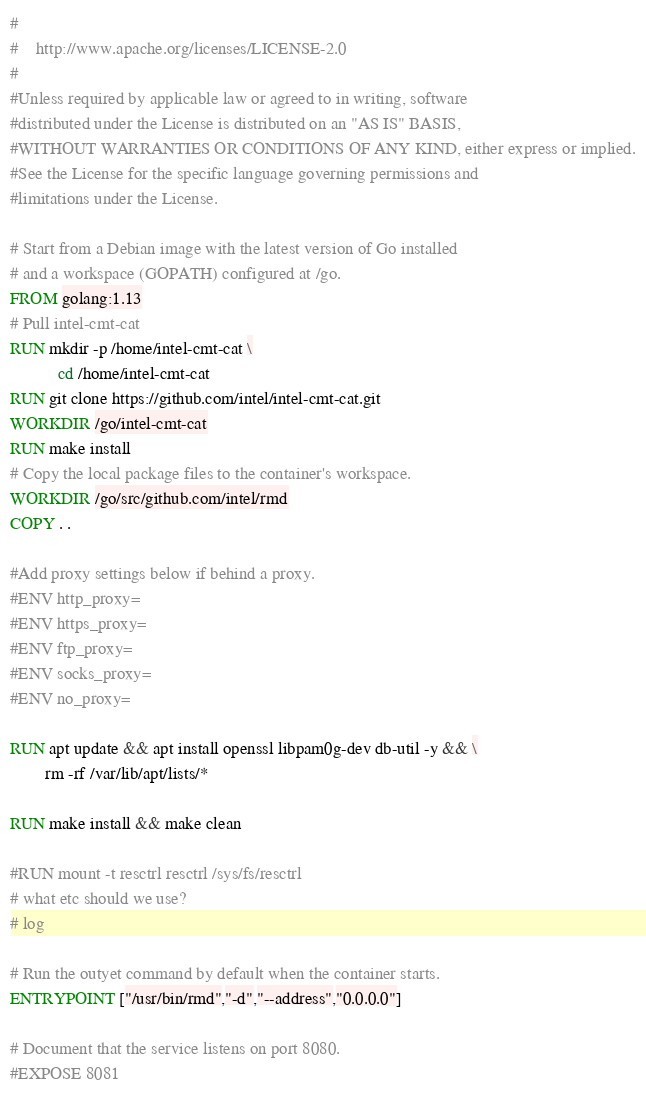<code> <loc_0><loc_0><loc_500><loc_500><_Dockerfile_>#
#    http://www.apache.org/licenses/LICENSE-2.0
#
#Unless required by applicable law or agreed to in writing, software
#distributed under the License is distributed on an "AS IS" BASIS,
#WITHOUT WARRANTIES OR CONDITIONS OF ANY KIND, either express or implied.
#See the License for the specific language governing permissions and
#limitations under the License.

# Start from a Debian image with the latest version of Go installed
# and a workspace (GOPATH) configured at /go.
FROM golang:1.13  
# Pull intel-cmt-cat
RUN mkdir -p /home/intel-cmt-cat \
           cd /home/intel-cmt-cat
RUN git clone https://github.com/intel/intel-cmt-cat.git
WORKDIR /go/intel-cmt-cat
RUN make install
# Copy the local package files to the container's workspace.
WORKDIR /go/src/github.com/intel/rmd
COPY . .

#Add proxy settings below if behind a proxy.
#ENV http_proxy=
#ENV https_proxy=
#ENV ftp_proxy=
#ENV socks_proxy=
#ENV no_proxy=

RUN apt update && apt install openssl libpam0g-dev db-util -y && \
        rm -rf /var/lib/apt/lists/*

RUN make install && make clean

#RUN mount -t resctrl resctrl /sys/fs/resctrl
# what etc should we use?
# log

# Run the outyet command by default when the container starts.
ENTRYPOINT ["/usr/bin/rmd","-d","--address","0.0.0.0"]

# Document that the service listens on port 8080.
#EXPOSE 8081
</code> 